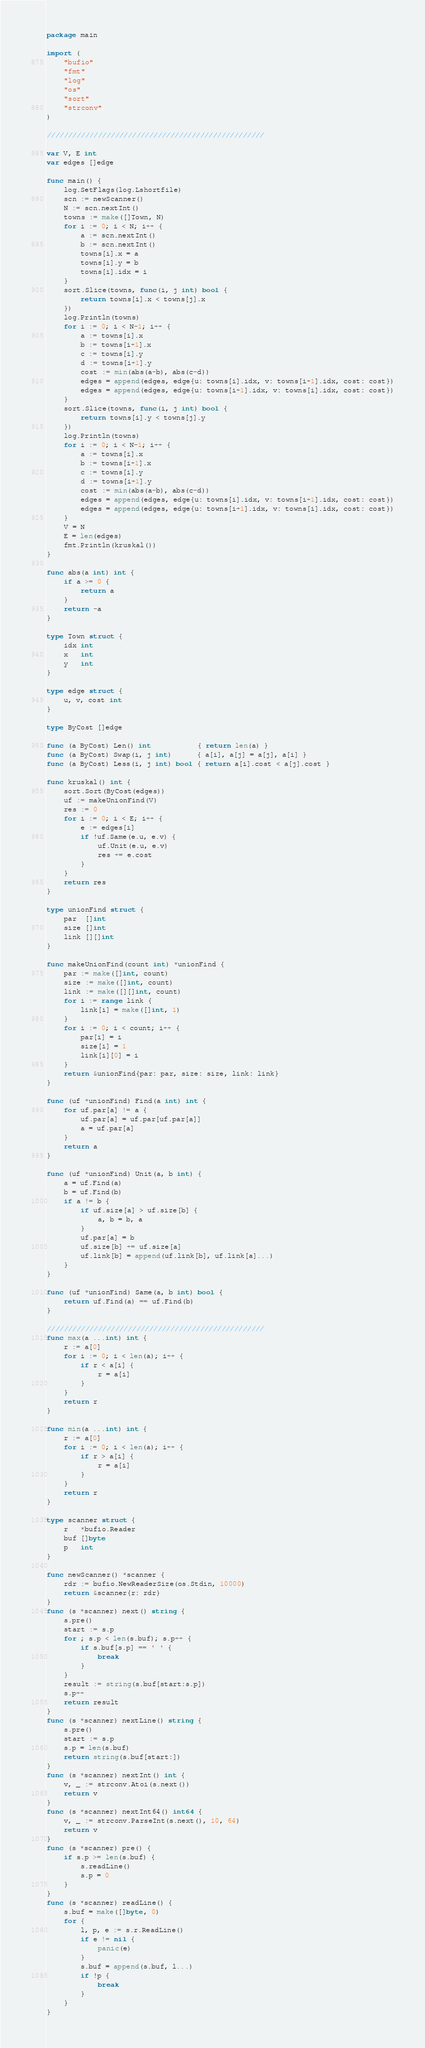Convert code to text. <code><loc_0><loc_0><loc_500><loc_500><_Go_>package main

import (
	"bufio"
	"fmt"
	"log"
	"os"
	"sort"
	"strconv"
)

///////////////////////////////////////////////////

var V, E int
var edges []edge

func main() {
	log.SetFlags(log.Lshortfile)
	scn := newScanner()
	N := scn.nextInt()
	towns := make([]Town, N)
	for i := 0; i < N; i++ {
		a := scn.nextInt()
		b := scn.nextInt()
		towns[i].x = a
		towns[i].y = b
		towns[i].idx = i
	}
	sort.Slice(towns, func(i, j int) bool {
		return towns[i].x < towns[j].x
	})
	log.Println(towns)
	for i := 0; i < N-1; i++ {
		a := towns[i].x
		b := towns[i+1].x
		c := towns[i].y
		d := towns[i+1].y
		cost := min(abs(a-b), abs(c-d))
		edges = append(edges, edge{u: towns[i].idx, v: towns[i+1].idx, cost: cost})
		edges = append(edges, edge{u: towns[i+1].idx, v: towns[i].idx, cost: cost})
	}
	sort.Slice(towns, func(i, j int) bool {
		return towns[i].y < towns[j].y
	})
	log.Println(towns)
	for i := 0; i < N-1; i++ {
		a := towns[i].x
		b := towns[i+1].x
		c := towns[i].y
		d := towns[i+1].y
		cost := min(abs(a-b), abs(c-d))
		edges = append(edges, edge{u: towns[i].idx, v: towns[i+1].idx, cost: cost})
		edges = append(edges, edge{u: towns[i+1].idx, v: towns[i].idx, cost: cost})
	}
	V = N
	E = len(edges)
	fmt.Println(kruskal())
}

func abs(a int) int {
	if a >= 0 {
		return a
	}
	return -a
}

type Town struct {
	idx int
	x   int
	y   int
}

type edge struct {
	u, v, cost int
}

type ByCost []edge

func (a ByCost) Len() int           { return len(a) }
func (a ByCost) Swap(i, j int)      { a[i], a[j] = a[j], a[i] }
func (a ByCost) Less(i, j int) bool { return a[i].cost < a[j].cost }

func kruskal() int {
	sort.Sort(ByCost(edges))
	uf := makeUnionFind(V)
	res := 0
	for i := 0; i < E; i++ {
		e := edges[i]
		if !uf.Same(e.u, e.v) {
			uf.Unit(e.u, e.v)
			res += e.cost
		}
	}
	return res
}

type unionFind struct {
	par  []int
	size []int
	link [][]int
}

func makeUnionFind(count int) *unionFind {
	par := make([]int, count)
	size := make([]int, count)
	link := make([][]int, count)
	for i := range link {
		link[i] = make([]int, 1)
	}
	for i := 0; i < count; i++ {
		par[i] = i
		size[i] = 1
		link[i][0] = i
	}
	return &unionFind{par: par, size: size, link: link}
}

func (uf *unionFind) Find(a int) int {
	for uf.par[a] != a {
		uf.par[a] = uf.par[uf.par[a]]
		a = uf.par[a]
	}
	return a
}

func (uf *unionFind) Unit(a, b int) {
	a = uf.Find(a)
	b = uf.Find(b)
	if a != b {
		if uf.size[a] > uf.size[b] {
			a, b = b, a
		}
		uf.par[a] = b
		uf.size[b] += uf.size[a]
		uf.link[b] = append(uf.link[b], uf.link[a]...)
	}
}

func (uf *unionFind) Same(a, b int) bool {
	return uf.Find(a) == uf.Find(b)
}

///////////////////////////////////////////////////
func max(a ...int) int {
	r := a[0]
	for i := 0; i < len(a); i++ {
		if r < a[i] {
			r = a[i]
		}
	}
	return r
}

func min(a ...int) int {
	r := a[0]
	for i := 0; i < len(a); i++ {
		if r > a[i] {
			r = a[i]
		}
	}
	return r
}

type scanner struct {
	r   *bufio.Reader
	buf []byte
	p   int
}

func newScanner() *scanner {
	rdr := bufio.NewReaderSize(os.Stdin, 10000)
	return &scanner{r: rdr}
}
func (s *scanner) next() string {
	s.pre()
	start := s.p
	for ; s.p < len(s.buf); s.p++ {
		if s.buf[s.p] == ' ' {
			break
		}
	}
	result := string(s.buf[start:s.p])
	s.p++
	return result
}
func (s *scanner) nextLine() string {
	s.pre()
	start := s.p
	s.p = len(s.buf)
	return string(s.buf[start:])
}
func (s *scanner) nextInt() int {
	v, _ := strconv.Atoi(s.next())
	return v
}
func (s *scanner) nextInt64() int64 {
	v, _ := strconv.ParseInt(s.next(), 10, 64)
	return v
}
func (s *scanner) pre() {
	if s.p >= len(s.buf) {
		s.readLine()
		s.p = 0
	}
}
func (s *scanner) readLine() {
	s.buf = make([]byte, 0)
	for {
		l, p, e := s.r.ReadLine()
		if e != nil {
			panic(e)
		}
		s.buf = append(s.buf, l...)
		if !p {
			break
		}
	}
}
</code> 